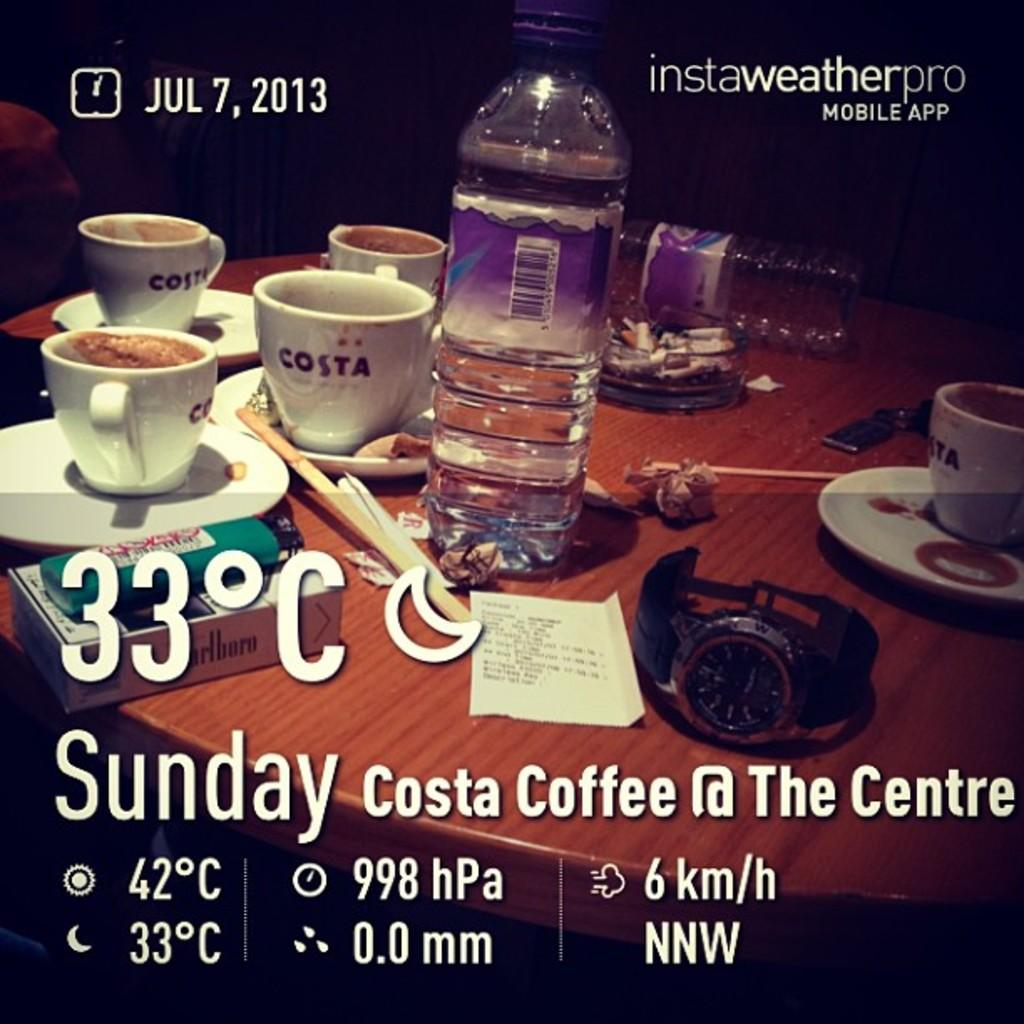<image>
Share a concise interpretation of the image provided. Screen showing a table top and the date on July 7th. 